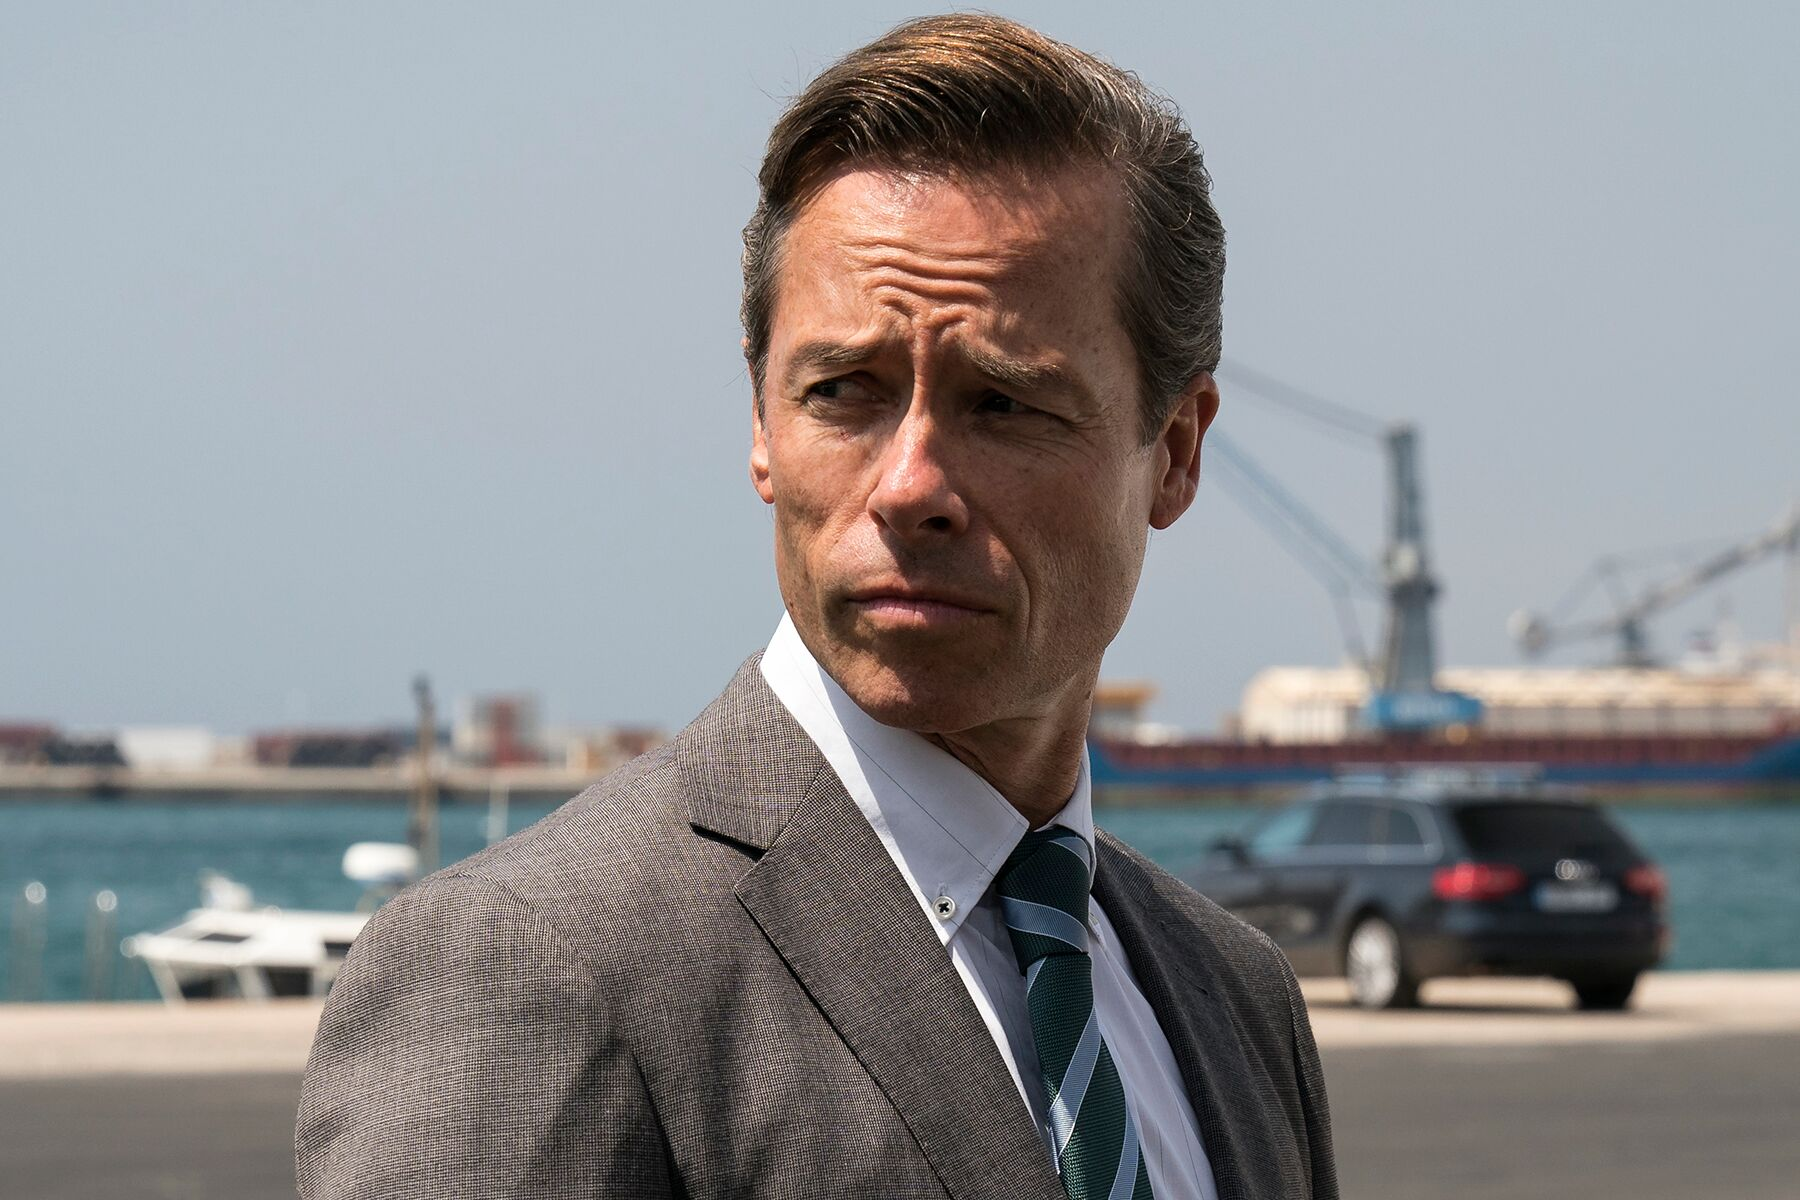If this was the opening scene of a movie, describe an intriguing plot that could follow. The film opens with a focused shot of a man, impeccably dressed, standing by a busy port. As the camera pulls back, we see the sprawling maritime industry behind him, symbolizing his pivotal role in this vast network. The plot thickens as a mysterious shipment arrives, leading to a series of unforeseen events. The man, revealed to be a high-ranking official in an international logistics corporation, finds himself entangled in a web of corporate espionage, smuggling, and a grand scheme to disrupt global trade. His quest to uncover the truth leads him across continents, facing adversaries in high-stakes negotiations, uncovering covert operations, and even forming uneasy alliances with former rivals. The story layers elements of thriller, drama, and action as the protagonist navigates through deception, betrayal, and danger, all while trying to protect his company and loved ones from impending chaos. 